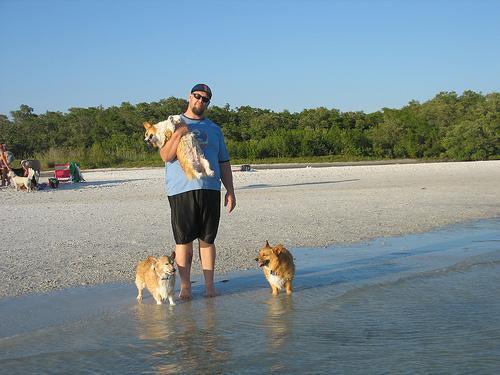How many men are there?
Give a very brief answer. 1. 